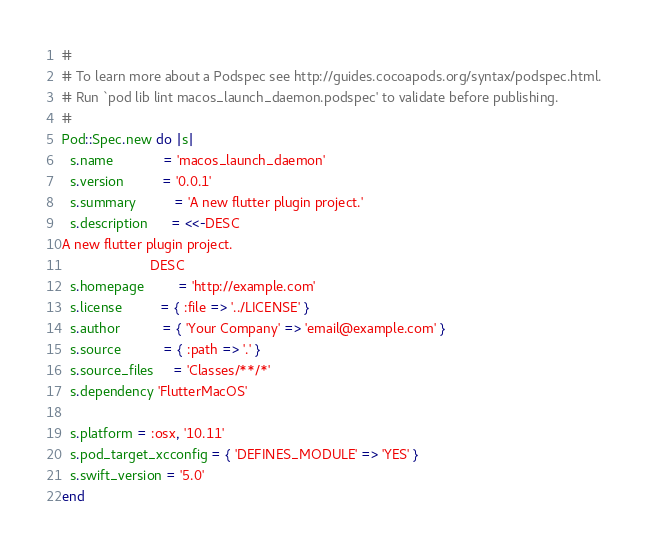Convert code to text. <code><loc_0><loc_0><loc_500><loc_500><_Ruby_>#
# To learn more about a Podspec see http://guides.cocoapods.org/syntax/podspec.html.
# Run `pod lib lint macos_launch_daemon.podspec' to validate before publishing.
#
Pod::Spec.new do |s|
  s.name             = 'macos_launch_daemon'
  s.version          = '0.0.1'
  s.summary          = 'A new flutter plugin project.'
  s.description      = <<-DESC
A new flutter plugin project.
                       DESC
  s.homepage         = 'http://example.com'
  s.license          = { :file => '../LICENSE' }
  s.author           = { 'Your Company' => 'email@example.com' }
  s.source           = { :path => '.' }
  s.source_files     = 'Classes/**/*'
  s.dependency 'FlutterMacOS'

  s.platform = :osx, '10.11'
  s.pod_target_xcconfig = { 'DEFINES_MODULE' => 'YES' }
  s.swift_version = '5.0'
end
</code> 